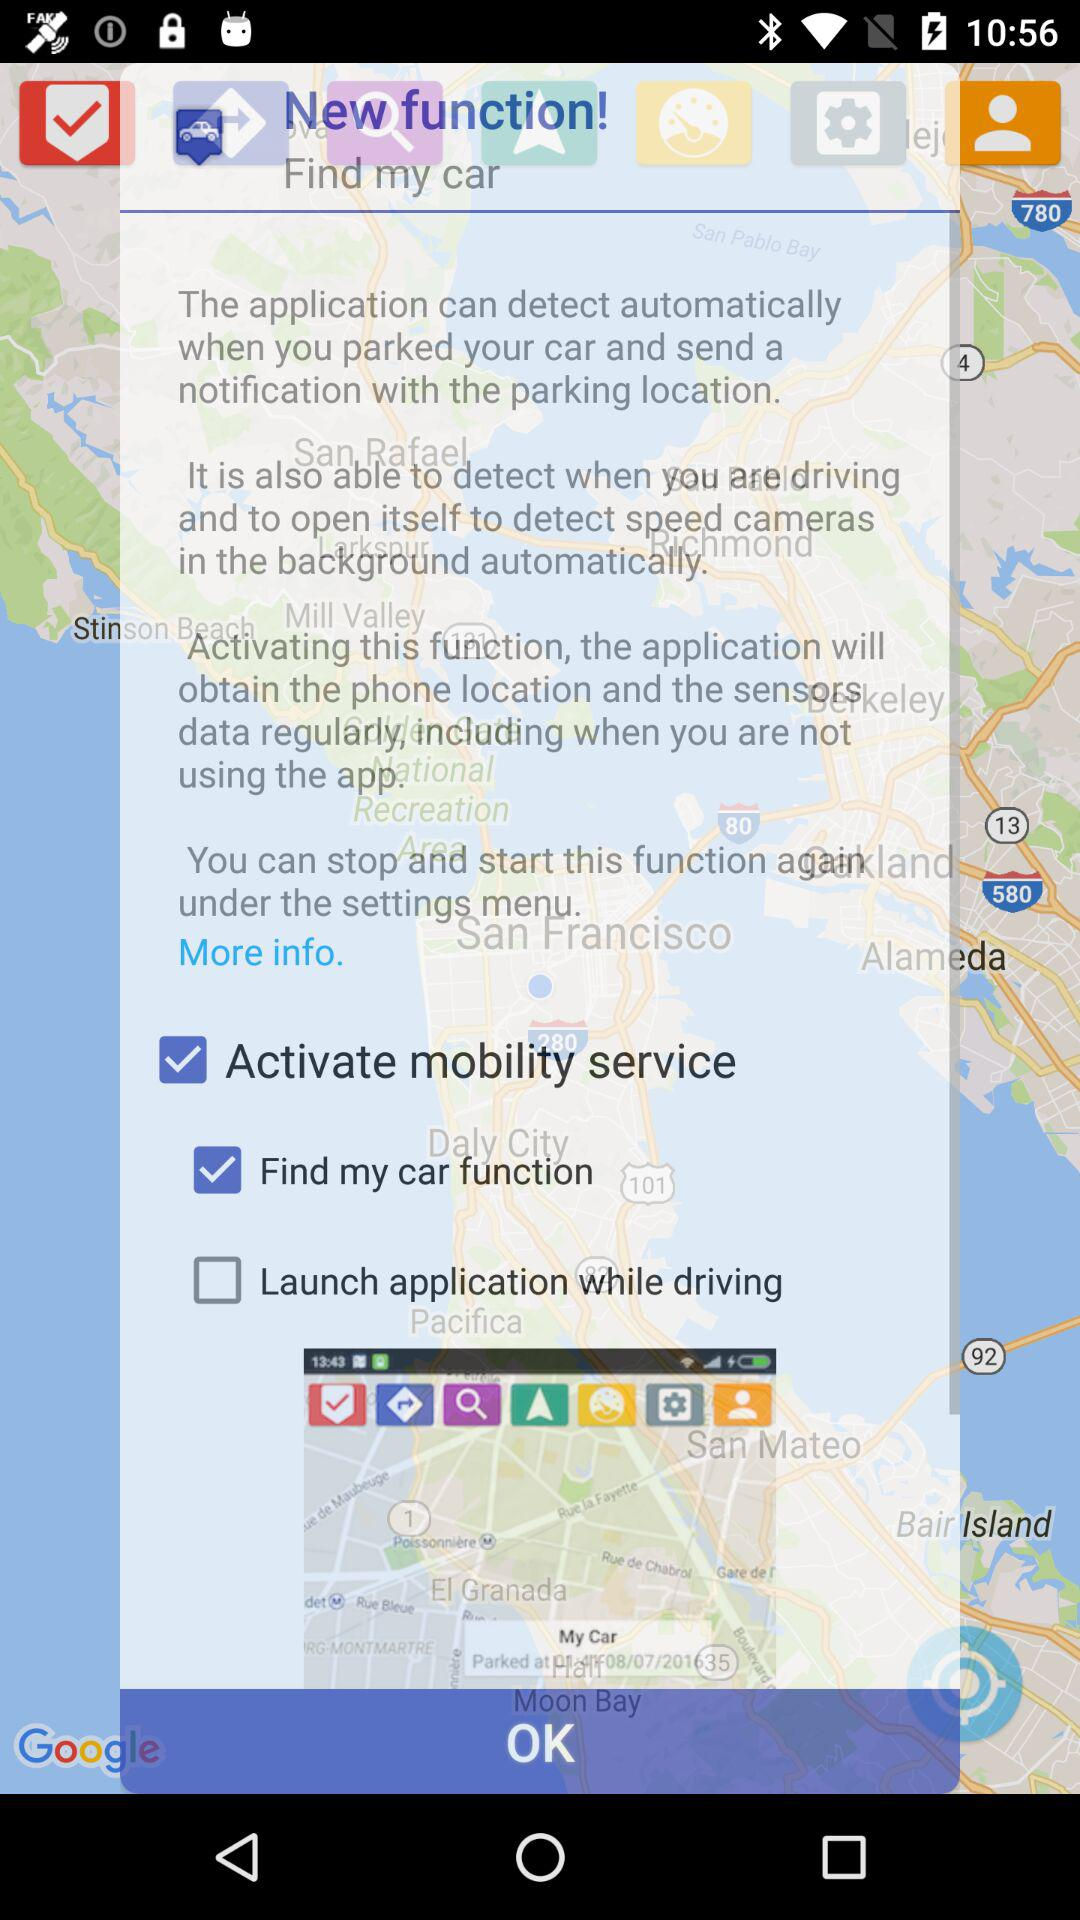What is the status of the "Find my car function"? The status of the "Find my car function" is "on". 